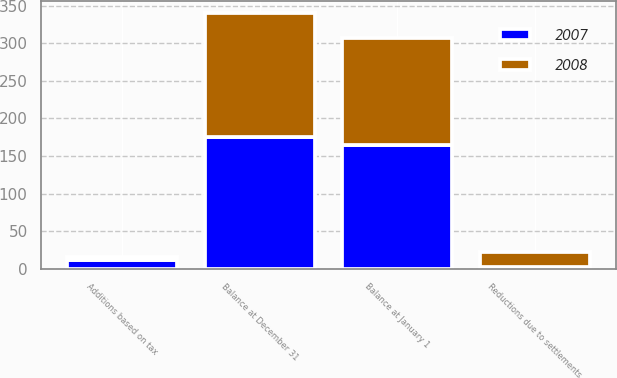Convert chart to OTSL. <chart><loc_0><loc_0><loc_500><loc_500><stacked_bar_chart><ecel><fcel>Balance at January 1<fcel>Additions based on tax<fcel>Reductions due to settlements<fcel>Balance at December 31<nl><fcel>2007<fcel>165<fcel>11<fcel>2<fcel>175<nl><fcel>2008<fcel>142<fcel>5<fcel>20<fcel>165<nl></chart> 